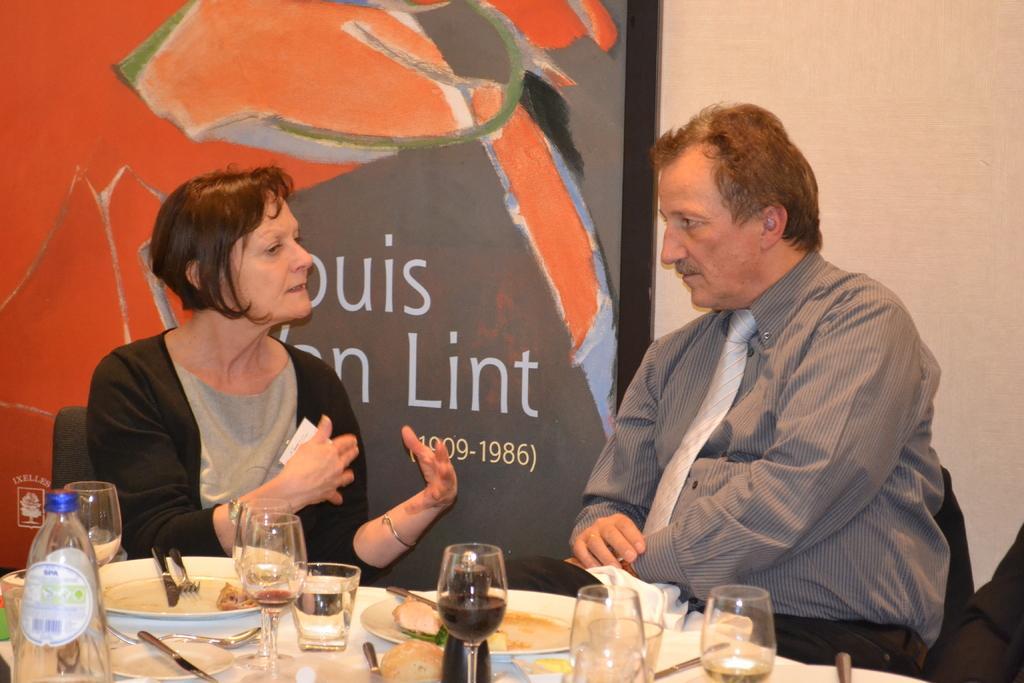How would you summarize this image in a sentence or two? In this image there are two people sitting and talking before them there is a table. On the table there are glasses, plates, forks, knives, bottles and some food. In the background there is a board and wall. 